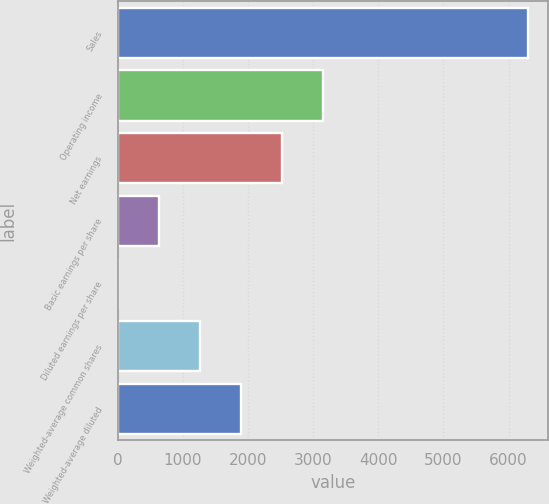<chart> <loc_0><loc_0><loc_500><loc_500><bar_chart><fcel>Sales<fcel>Operating income<fcel>Net earnings<fcel>Basic earnings per share<fcel>Diluted earnings per share<fcel>Weighted-average common shares<fcel>Weighted-average diluted<nl><fcel>6294<fcel>3148.04<fcel>2518.84<fcel>631.25<fcel>2.05<fcel>1260.45<fcel>1889.64<nl></chart> 